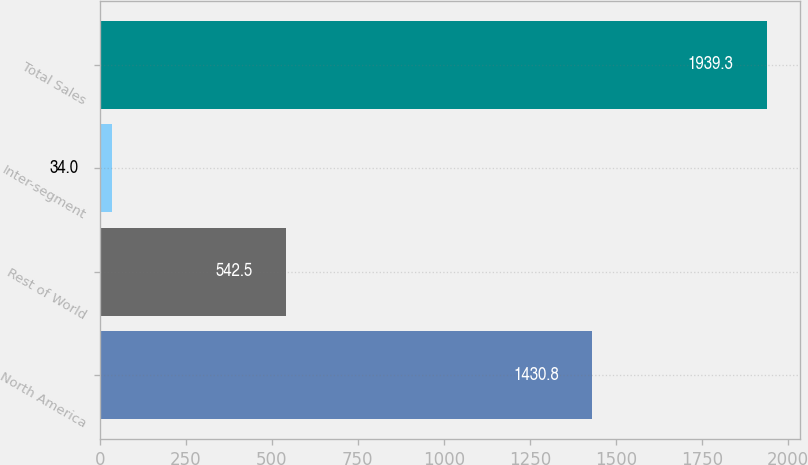Convert chart to OTSL. <chart><loc_0><loc_0><loc_500><loc_500><bar_chart><fcel>North America<fcel>Rest of World<fcel>Inter-segment<fcel>Total Sales<nl><fcel>1430.8<fcel>542.5<fcel>34<fcel>1939.3<nl></chart> 